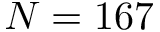Convert formula to latex. <formula><loc_0><loc_0><loc_500><loc_500>N = 1 6 7</formula> 